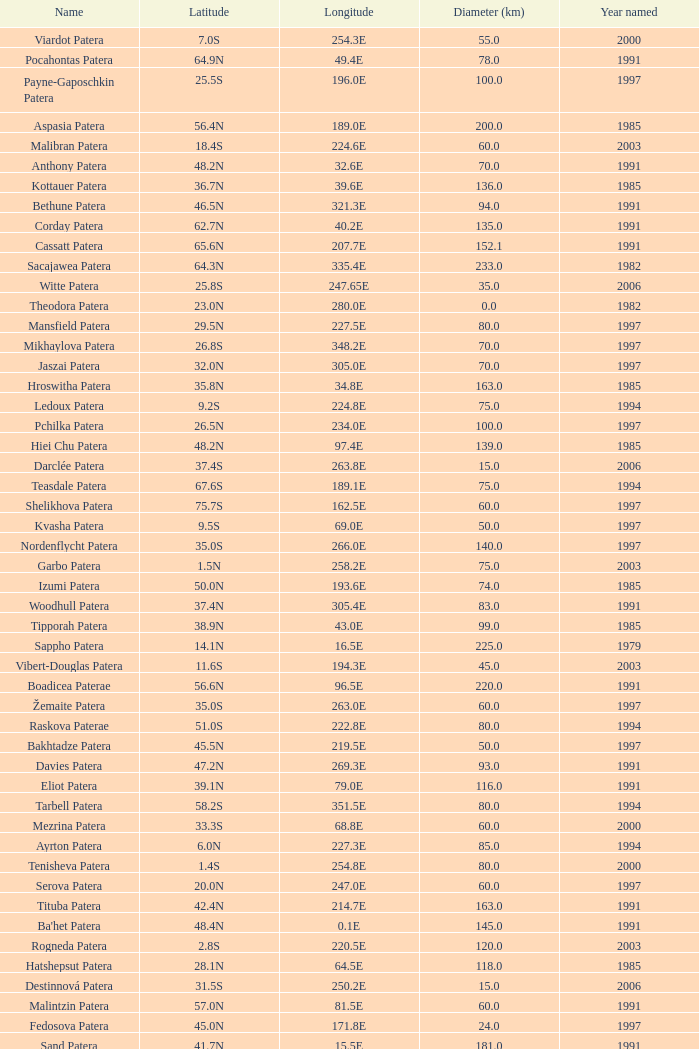What is Year Named, when Longitude is 227.5E? 1997.0. 